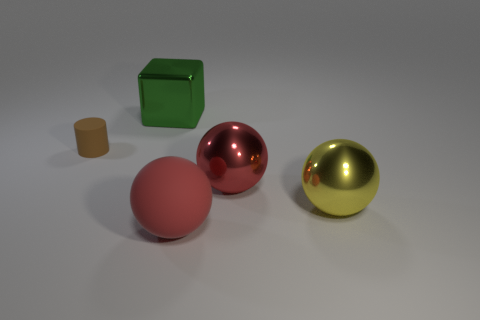What is the light source in the image? The light source isn't directly visible, but it appears to be emanating from above, casting shadows beneath the objects and giving them highlights that suggest a single overhead light. Can you infer anything about the environment based on the shadows and reflections? The shadows are soft and the reflections are diffuse, indicating the environment might be softly lit and the surfaces have a matte quality, possibly in an indoor setting with indirect lighting. 